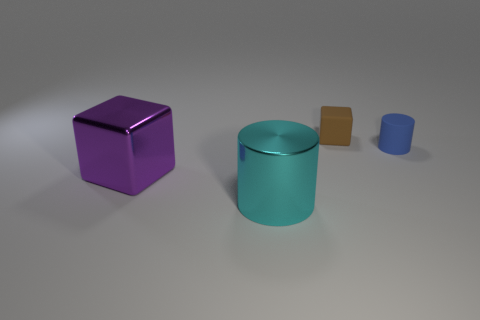What number of objects are purple objects or blocks?
Provide a succinct answer. 2. There is a small thing behind the blue cylinder; is its shape the same as the big metallic object that is in front of the shiny block?
Your response must be concise. No. The thing behind the small blue thing has what shape?
Ensure brevity in your answer.  Cube. Is the number of small brown objects that are in front of the tiny brown matte block the same as the number of brown matte things that are behind the shiny cylinder?
Give a very brief answer. No. How many objects are either metal cylinders or cylinders to the left of the blue cylinder?
Ensure brevity in your answer.  1. There is a thing that is on the right side of the big purple object and in front of the blue cylinder; what shape is it?
Your answer should be compact. Cylinder. What material is the large object left of the thing in front of the purple shiny object made of?
Your answer should be very brief. Metal. Is the material of the object that is right of the brown matte cube the same as the small cube?
Keep it short and to the point. Yes. How big is the cylinder in front of the large purple thing?
Give a very brief answer. Large. Is there a brown object that is in front of the metal thing in front of the purple shiny object?
Keep it short and to the point. No. 